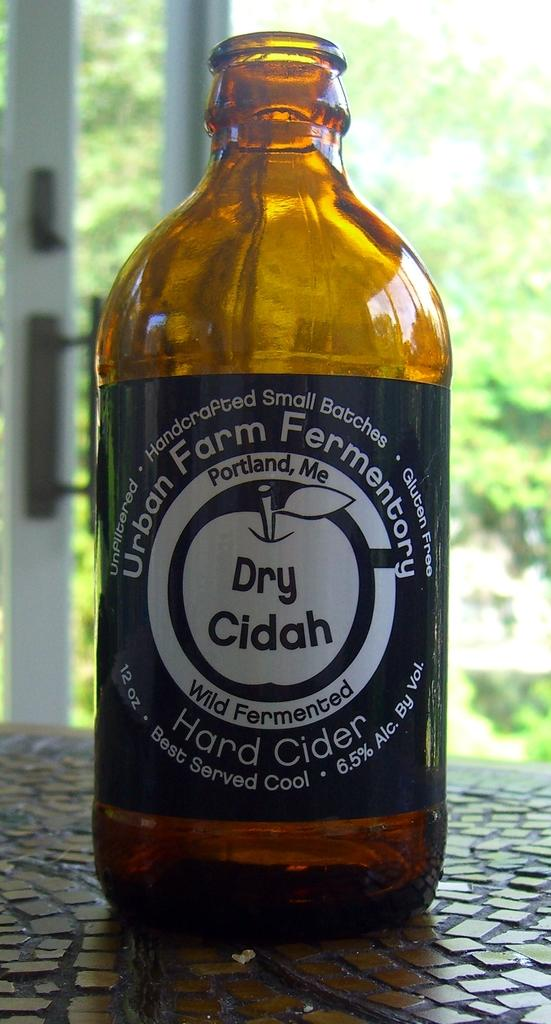Provide a one-sentence caption for the provided image. An empty bottle of Urban Farms dry cider. 